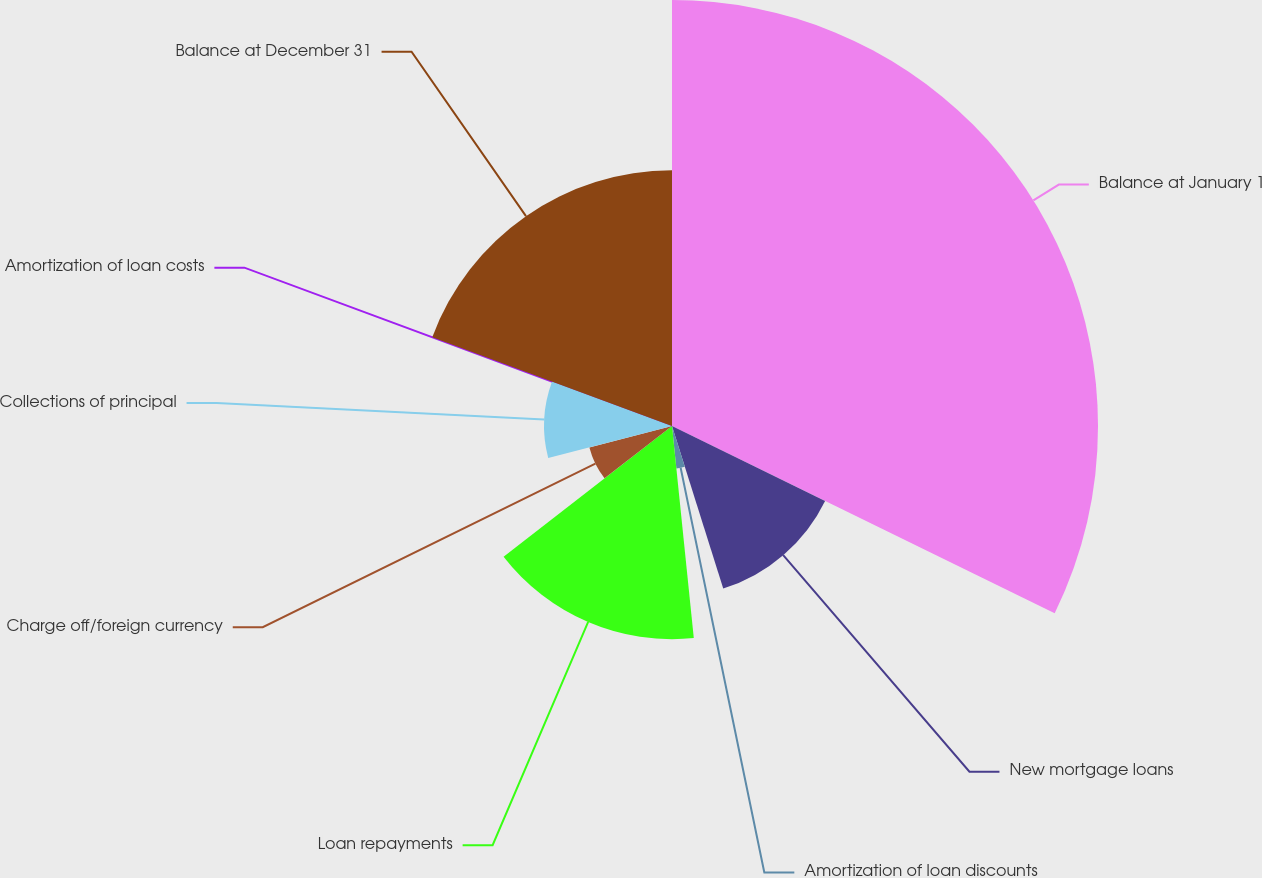Convert chart. <chart><loc_0><loc_0><loc_500><loc_500><pie_chart><fcel>Balance at January 1<fcel>New mortgage loans<fcel>Amortization of loan discounts<fcel>Loan repayments<fcel>Charge off/foreign currency<fcel>Collections of principal<fcel>Amortization of loan costs<fcel>Balance at December 31<nl><fcel>32.24%<fcel>12.9%<fcel>3.23%<fcel>16.13%<fcel>6.46%<fcel>9.68%<fcel>0.01%<fcel>19.35%<nl></chart> 